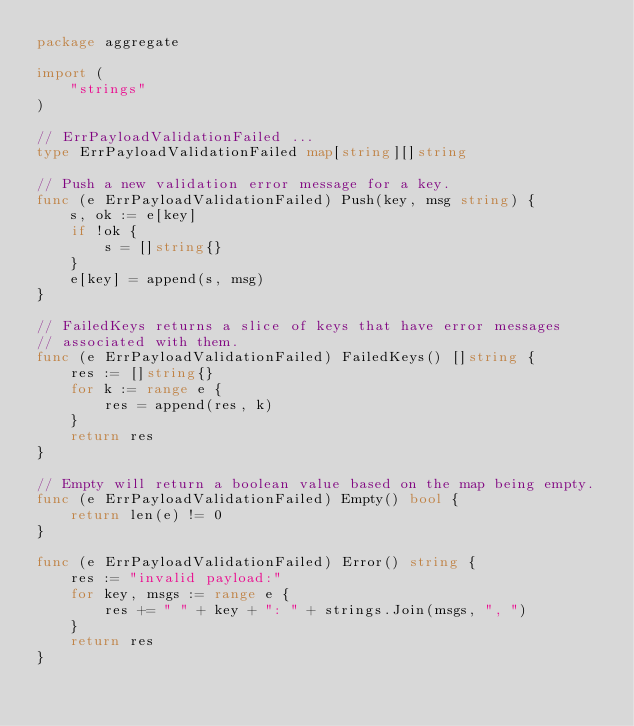<code> <loc_0><loc_0><loc_500><loc_500><_Go_>package aggregate

import (
	"strings"
)

// ErrPayloadValidationFailed ...
type ErrPayloadValidationFailed map[string][]string

// Push a new validation error message for a key.
func (e ErrPayloadValidationFailed) Push(key, msg string) {
	s, ok := e[key]
	if !ok {
		s = []string{}
	}
	e[key] = append(s, msg)
}

// FailedKeys returns a slice of keys that have error messages
// associated with them.
func (e ErrPayloadValidationFailed) FailedKeys() []string {
	res := []string{}
	for k := range e {
		res = append(res, k)
	}
	return res
}

// Empty will return a boolean value based on the map being empty.
func (e ErrPayloadValidationFailed) Empty() bool {
	return len(e) != 0
}

func (e ErrPayloadValidationFailed) Error() string {
	res := "invalid payload:"
	for key, msgs := range e {
		res += " " + key + ": " + strings.Join(msgs, ", ")
	}
	return res
}
</code> 